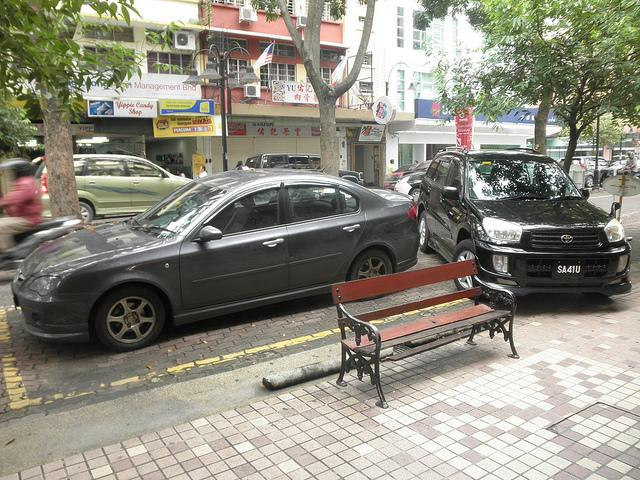Which car violates the law?

Choices:
A) black car
B) green car
C) red car
D) silver car black car 